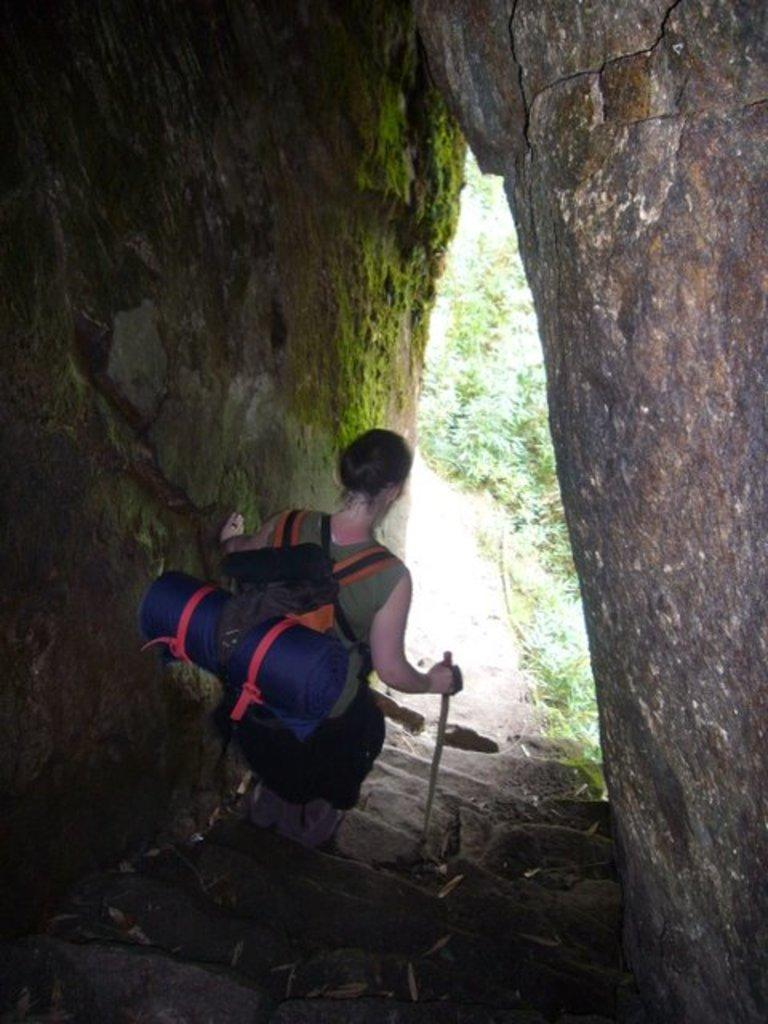Who is present in the image? There is a woman in the image. What is the woman holding in the image? The woman is holding a stick. What else is the woman carrying in the image? The woman is carrying a bag. What type of natural growth can be seen in the image? There are plants visible in the image. What architectural features are present in the image? There are walls and steps in the image. What is the water-related element in the image? There is algae visible in the image. What type of wire is being used to hold the soda in the image? There is no soda or wire present in the image. 